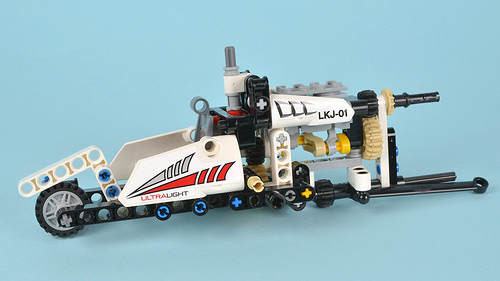<image>
Can you confirm if the plus is to the right of the plus? Yes. From this viewpoint, the plus is positioned to the right side relative to the plus. 